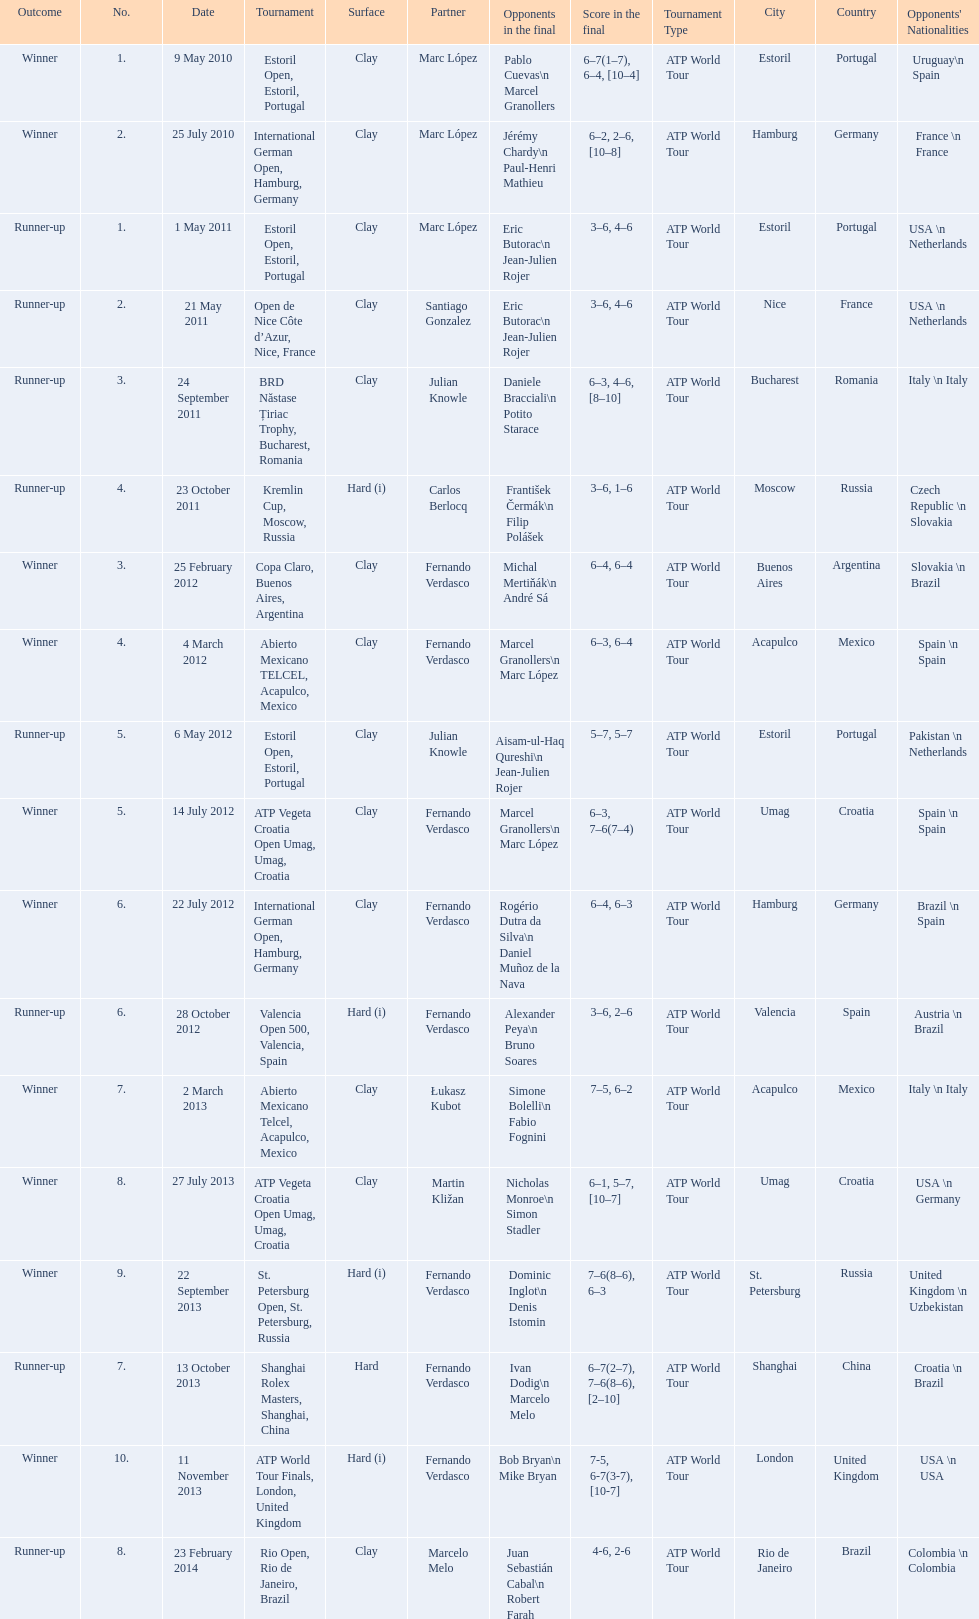How many contests has this player triumphed in during his professional journey thus far? 10. 